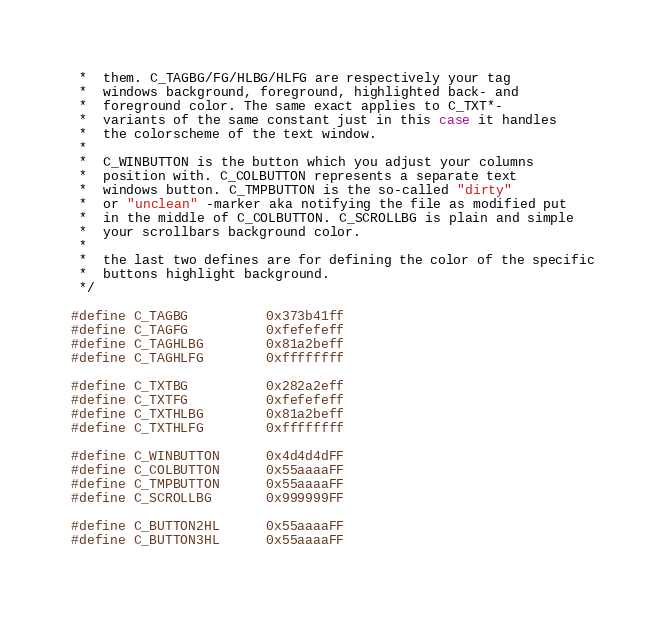Convert code to text. <code><loc_0><loc_0><loc_500><loc_500><_C_> *  them. C_TAGBG/FG/HLBG/HLFG are respectively your tag
 *  windows background, foreground, highlighted back- and
 *  foreground color. The same exact applies to C_TXT*-
 *  variants of the same constant just in this case it handles
 *  the colorscheme of the text window.
 *
 *  C_WINBUTTON is the button which you adjust your columns
 *  position with. C_COLBUTTON represents a separate text
 *  windows button. C_TMPBUTTON is the so-called "dirty"
 *  or "unclean" -marker aka notifying the file as modified put
 *  in the middle of C_COLBUTTON. C_SCROLLBG is plain and simple
 *  your scrollbars background color.
 *
 *  the last two defines are for defining the color of the specific
 *  buttons highlight background.
 */

#define C_TAGBG			0x373b41ff
#define C_TAGFG			0xfefefeff
#define C_TAGHLBG		0x81a2beff
#define C_TAGHLFG		0xffffffff

#define C_TXTBG			0x282a2eff
#define C_TXTFG			0xfefefeff
#define C_TXTHLBG		0x81a2beff
#define C_TXTHLFG		0xffffffff

#define C_WINBUTTON		0x4d4d4dFF
#define C_COLBUTTON		0x55aaaaFF
#define C_TMPBUTTON		0x55aaaaFF
#define C_SCROLLBG		0x999999FF

#define C_BUTTON2HL		0x55aaaaFF
#define C_BUTTON3HL		0x55aaaaFF
</code> 